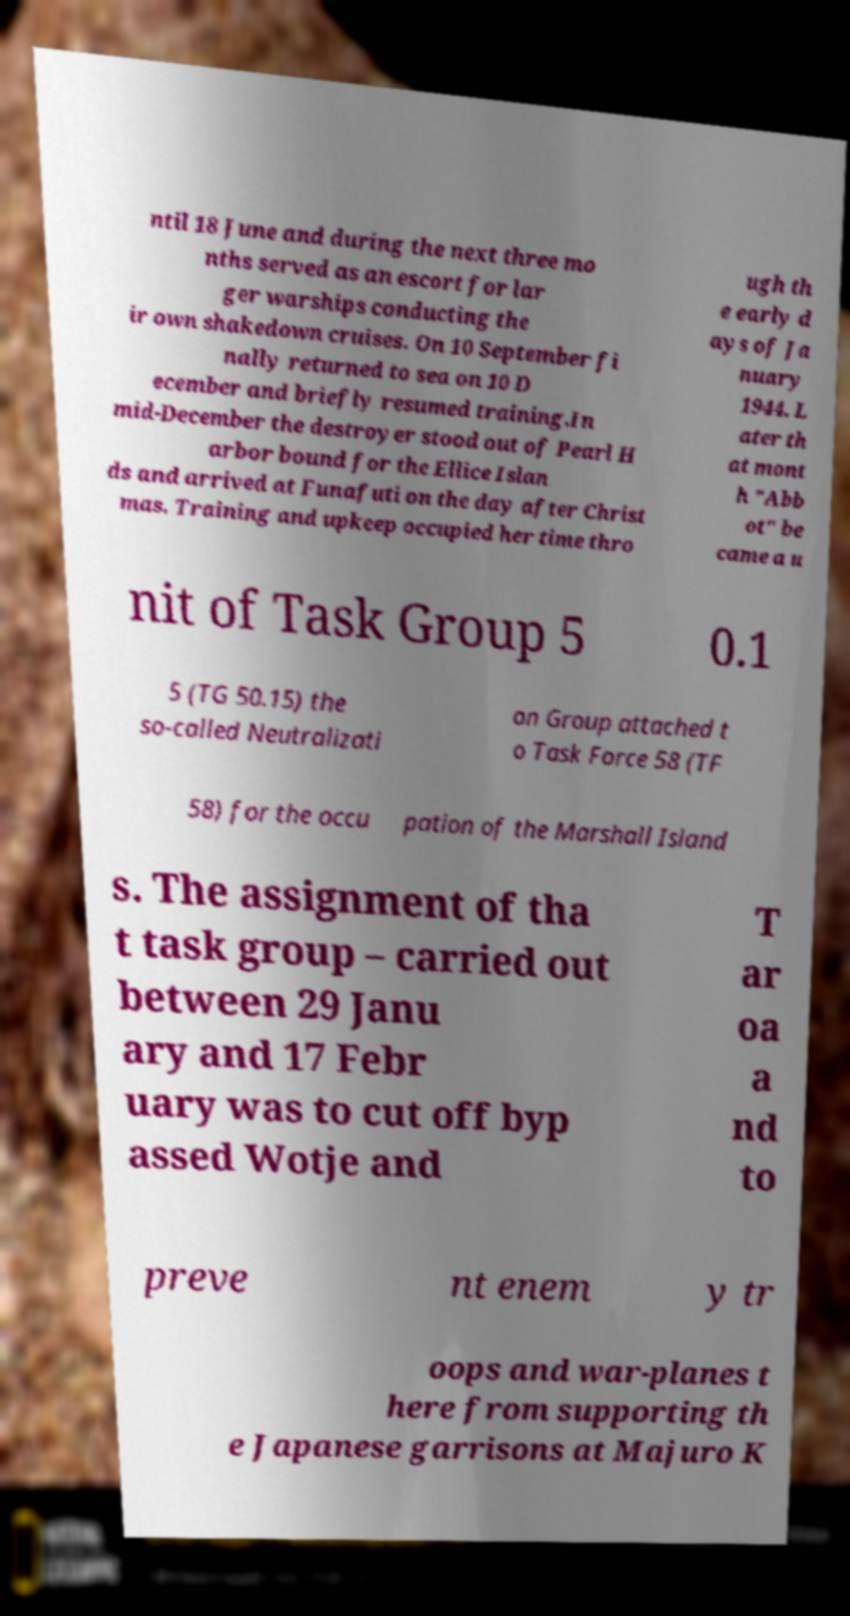There's text embedded in this image that I need extracted. Can you transcribe it verbatim? ntil 18 June and during the next three mo nths served as an escort for lar ger warships conducting the ir own shakedown cruises. On 10 September fi nally returned to sea on 10 D ecember and briefly resumed training.In mid-December the destroyer stood out of Pearl H arbor bound for the Ellice Islan ds and arrived at Funafuti on the day after Christ mas. Training and upkeep occupied her time thro ugh th e early d ays of Ja nuary 1944. L ater th at mont h "Abb ot" be came a u nit of Task Group 5 0.1 5 (TG 50.15) the so-called Neutralizati on Group attached t o Task Force 58 (TF 58) for the occu pation of the Marshall Island s. The assignment of tha t task group – carried out between 29 Janu ary and 17 Febr uary was to cut off byp assed Wotje and T ar oa a nd to preve nt enem y tr oops and war-planes t here from supporting th e Japanese garrisons at Majuro K 